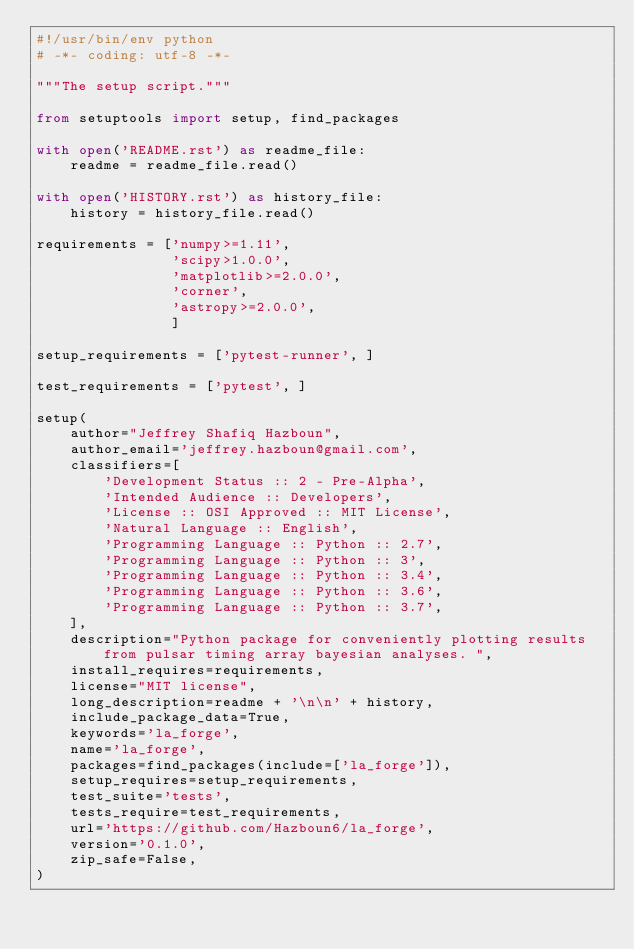Convert code to text. <code><loc_0><loc_0><loc_500><loc_500><_Python_>#!/usr/bin/env python
# -*- coding: utf-8 -*-

"""The setup script."""

from setuptools import setup, find_packages

with open('README.rst') as readme_file:
    readme = readme_file.read()

with open('HISTORY.rst') as history_file:
    history = history_file.read()

requirements = ['numpy>=1.11',
                'scipy>1.0.0',
                'matplotlib>=2.0.0',
                'corner',
                'astropy>=2.0.0',
                ]

setup_requirements = ['pytest-runner', ]

test_requirements = ['pytest', ]

setup(
    author="Jeffrey Shafiq Hazboun",
    author_email='jeffrey.hazboun@gmail.com',
    classifiers=[
        'Development Status :: 2 - Pre-Alpha',
        'Intended Audience :: Developers',
        'License :: OSI Approved :: MIT License',
        'Natural Language :: English',
        'Programming Language :: Python :: 2.7',
        'Programming Language :: Python :: 3',
        'Programming Language :: Python :: 3.4',
        'Programming Language :: Python :: 3.6',
        'Programming Language :: Python :: 3.7',
    ],
    description="Python package for conveniently plotting results from pulsar timing array bayesian analyses. ",
    install_requires=requirements,
    license="MIT license",
    long_description=readme + '\n\n' + history,
    include_package_data=True,
    keywords='la_forge',
    name='la_forge',
    packages=find_packages(include=['la_forge']),
    setup_requires=setup_requirements,
    test_suite='tests',
    tests_require=test_requirements,
    url='https://github.com/Hazboun6/la_forge',
    version='0.1.0',
    zip_safe=False,
)
</code> 